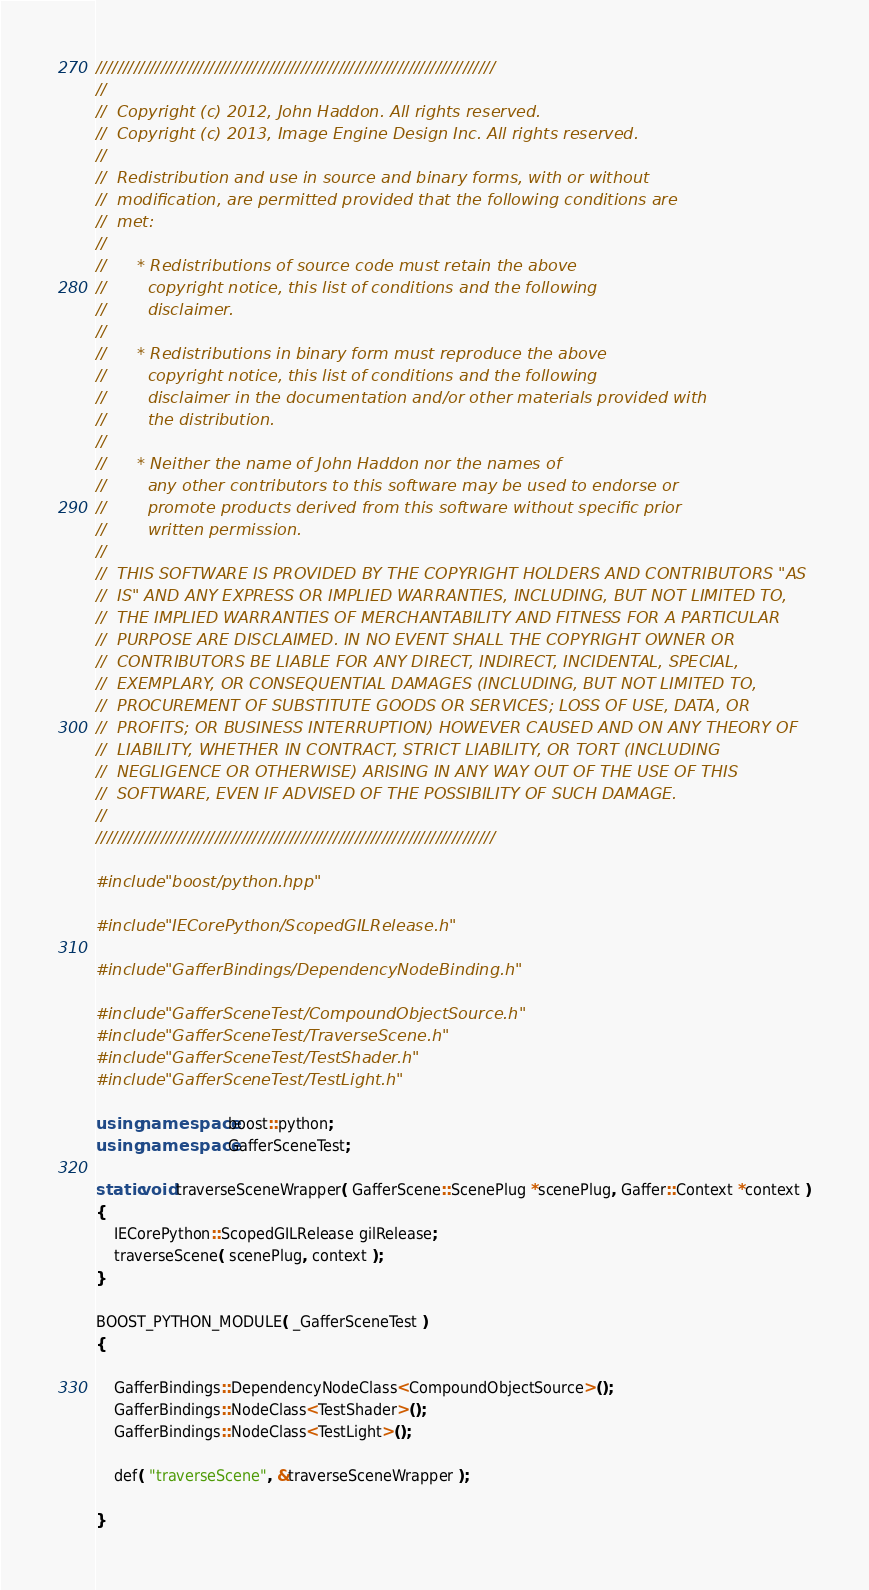<code> <loc_0><loc_0><loc_500><loc_500><_C++_>//////////////////////////////////////////////////////////////////////////
//  
//  Copyright (c) 2012, John Haddon. All rights reserved.
//  Copyright (c) 2013, Image Engine Design Inc. All rights reserved.
//  
//  Redistribution and use in source and binary forms, with or without
//  modification, are permitted provided that the following conditions are
//  met:
//  
//      * Redistributions of source code must retain the above
//        copyright notice, this list of conditions and the following
//        disclaimer.
//  
//      * Redistributions in binary form must reproduce the above
//        copyright notice, this list of conditions and the following
//        disclaimer in the documentation and/or other materials provided with
//        the distribution.
//  
//      * Neither the name of John Haddon nor the names of
//        any other contributors to this software may be used to endorse or
//        promote products derived from this software without specific prior
//        written permission.
//  
//  THIS SOFTWARE IS PROVIDED BY THE COPYRIGHT HOLDERS AND CONTRIBUTORS "AS
//  IS" AND ANY EXPRESS OR IMPLIED WARRANTIES, INCLUDING, BUT NOT LIMITED TO,
//  THE IMPLIED WARRANTIES OF MERCHANTABILITY AND FITNESS FOR A PARTICULAR
//  PURPOSE ARE DISCLAIMED. IN NO EVENT SHALL THE COPYRIGHT OWNER OR
//  CONTRIBUTORS BE LIABLE FOR ANY DIRECT, INDIRECT, INCIDENTAL, SPECIAL,
//  EXEMPLARY, OR CONSEQUENTIAL DAMAGES (INCLUDING, BUT NOT LIMITED TO,
//  PROCUREMENT OF SUBSTITUTE GOODS OR SERVICES; LOSS OF USE, DATA, OR
//  PROFITS; OR BUSINESS INTERRUPTION) HOWEVER CAUSED AND ON ANY THEORY OF
//  LIABILITY, WHETHER IN CONTRACT, STRICT LIABILITY, OR TORT (INCLUDING
//  NEGLIGENCE OR OTHERWISE) ARISING IN ANY WAY OUT OF THE USE OF THIS
//  SOFTWARE, EVEN IF ADVISED OF THE POSSIBILITY OF SUCH DAMAGE.
//  
//////////////////////////////////////////////////////////////////////////

#include "boost/python.hpp"

#include "IECorePython/ScopedGILRelease.h"

#include "GafferBindings/DependencyNodeBinding.h"

#include "GafferSceneTest/CompoundObjectSource.h"
#include "GafferSceneTest/TraverseScene.h"
#include "GafferSceneTest/TestShader.h"
#include "GafferSceneTest/TestLight.h"

using namespace boost::python;
using namespace GafferSceneTest;

static void traverseSceneWrapper( GafferScene::ScenePlug *scenePlug, Gaffer::Context *context )
{
	IECorePython::ScopedGILRelease gilRelease;
	traverseScene( scenePlug, context );
}

BOOST_PYTHON_MODULE( _GafferSceneTest )
{
	
	GafferBindings::DependencyNodeClass<CompoundObjectSource>();
	GafferBindings::NodeClass<TestShader>();
	GafferBindings::NodeClass<TestLight>();

	def( "traverseScene", &traverseSceneWrapper );

}
</code> 